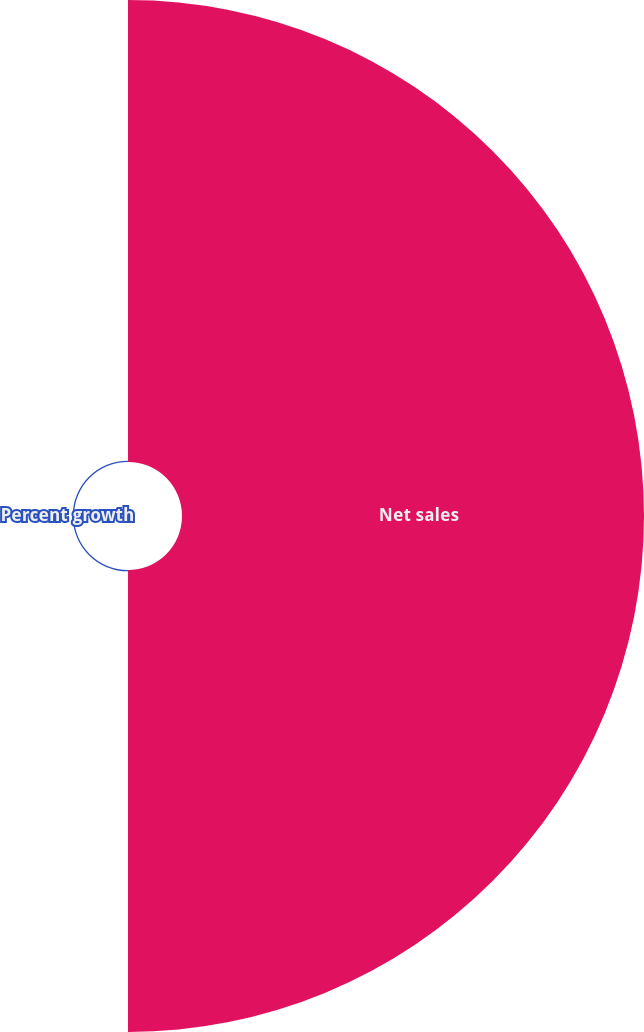Convert chart. <chart><loc_0><loc_0><loc_500><loc_500><pie_chart><fcel>Net sales<fcel>Percent growth<nl><fcel>99.71%<fcel>0.29%<nl></chart> 